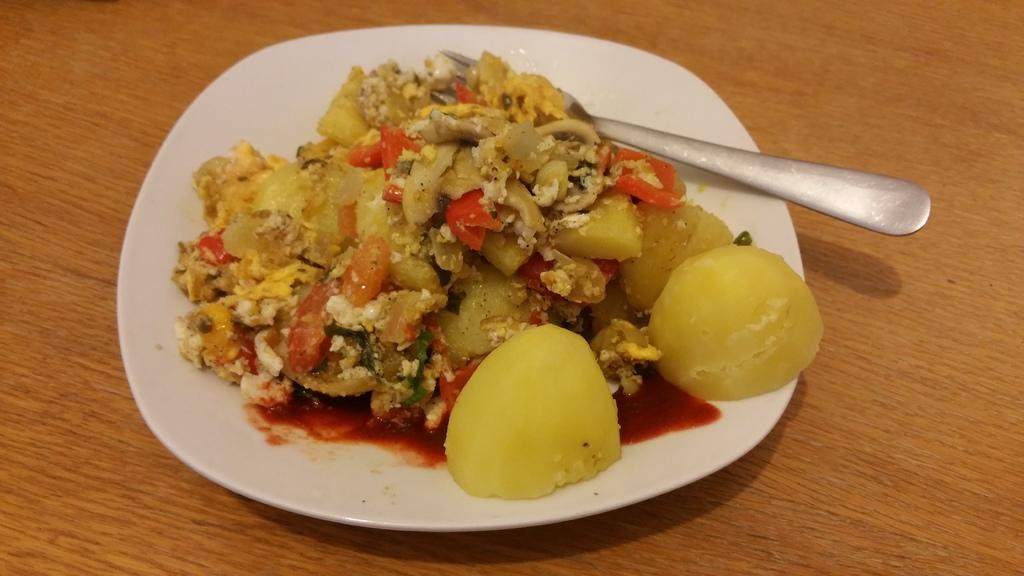What is on the plate that is visible in the image? The plate has food on it. What utensil is placed on the plate? There is a fork on the plate. Where is the plate located in the image? The plate is placed on a wooden plank. Can you see any ghosts interacting with the plate in the image? There are no ghosts present in the image. What type of tongue is used to eat the food on the plate in the image? The image does not show any tongues, as it is a still image and does not depict any actions or movements. 